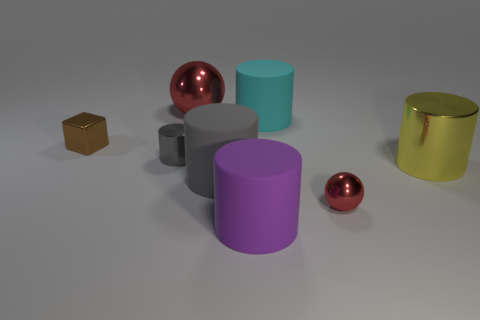There is a red ball that is behind the big cylinder to the right of the cyan thing; how big is it?
Keep it short and to the point. Large. Are there the same number of big red shiny objects in front of the big red metallic object and yellow things that are on the left side of the gray rubber thing?
Your response must be concise. Yes. There is a red shiny sphere behind the tiny metallic ball; is there a large cyan thing that is to the left of it?
Ensure brevity in your answer.  No. What is the shape of the tiny gray object that is made of the same material as the yellow object?
Offer a terse response. Cylinder. Is there anything else that is the same color as the tiny metal cylinder?
Keep it short and to the point. Yes. What is the red sphere on the right side of the large cylinder behind the yellow cylinder made of?
Offer a very short reply. Metal. Are there any other metal objects of the same shape as the gray shiny thing?
Your response must be concise. Yes. How many other things are there of the same shape as the big yellow metal thing?
Keep it short and to the point. 4. The shiny object that is both in front of the cyan cylinder and behind the tiny cylinder has what shape?
Provide a short and direct response. Cube. There is a metal sphere in front of the small gray thing; what is its size?
Provide a succinct answer. Small. 